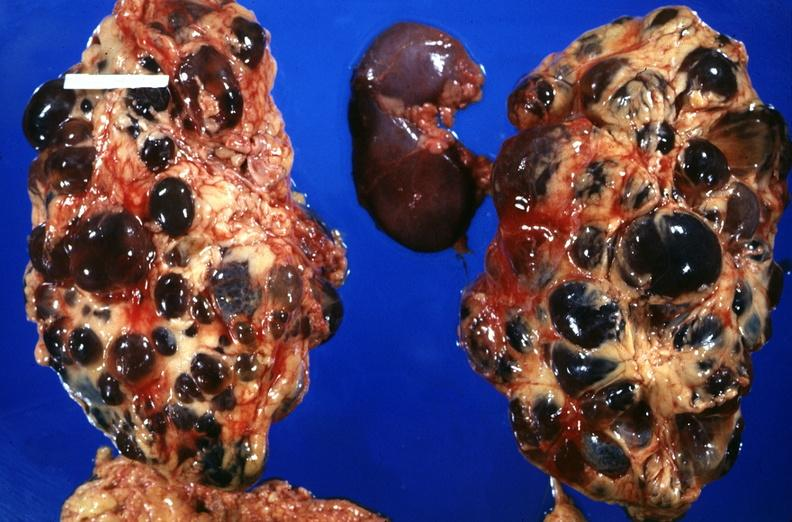where is this?
Answer the question using a single word or phrase. Urinary 